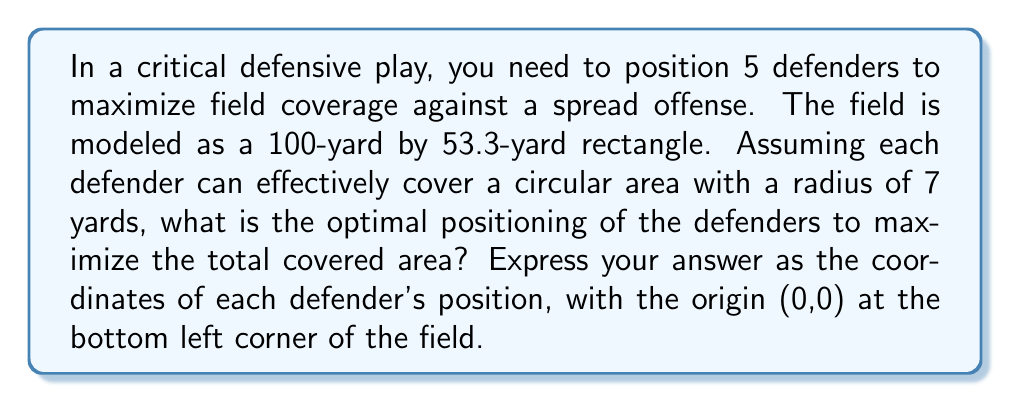Give your solution to this math problem. To solve this problem, we need to approach it like we're designing a defensive formation that gives us the best chance to cover the most ground. Here's how we break it down:

1) First, we need to understand that we're dealing with a geometric optimization problem. We want to maximize the area covered by 5 circles on a rectangle.

2) In mathematical terms, this is known as a circle packing problem. The optimal solution for packing circles in a rectangle is not always intuitive, but there are some principles we can follow.

3) Given the dimensions of the field (100 yards by 53.3 yards), we can see that the field is nearly twice as long as it is wide. This suggests we might want to position our defenders in a roughly 3-2 formation.

4) To maximize coverage, we want to minimize overlap between the circles while also minimizing uncovered space at the edges of the field.

5) A good approximation for this problem is to position the defenders in a hexagonal lattice pattern, which is known to be the densest circle packing in an infinite plane.

6) Given the field dimensions and the number of defenders, we can calculate the optimal positions as follows:

   - Place three defenders across the width of the field, equally spaced
   - Place two defenders in the gaps between these three, but shifted upfield

7) The mathematical representation of this would be:

   $$x_1 = 13.325, y_1 = 7$$
   $$x_2 = 40, y_2 = 7$$
   $$x_3 = 66.675, y_3 = 7$$
   $$x_4 = 26.65, y_4 = 19.14$$
   $$x_5 = 53.35, y_5 = 19.14$$

8) This formation provides good coverage across the width of the field while also providing depth to defend against deep plays.

9) The total area covered can be calculated as:

   $$A = 5 \cdot \pi r^2 = 5 \cdot \pi \cdot 7^2 \approx 769.69 \text{ square yards}$$

   Which is about 14.4% of the total field area.

This positioning strategy gives us a balanced defensive formation that maximizes field coverage while maintaining flexibility to respond to different offensive plays.
Answer: The optimal positions for the 5 defenders are:
(13.325, 7), (40, 7), (66.675, 7), (26.65, 19.14), (53.35, 19.14) 